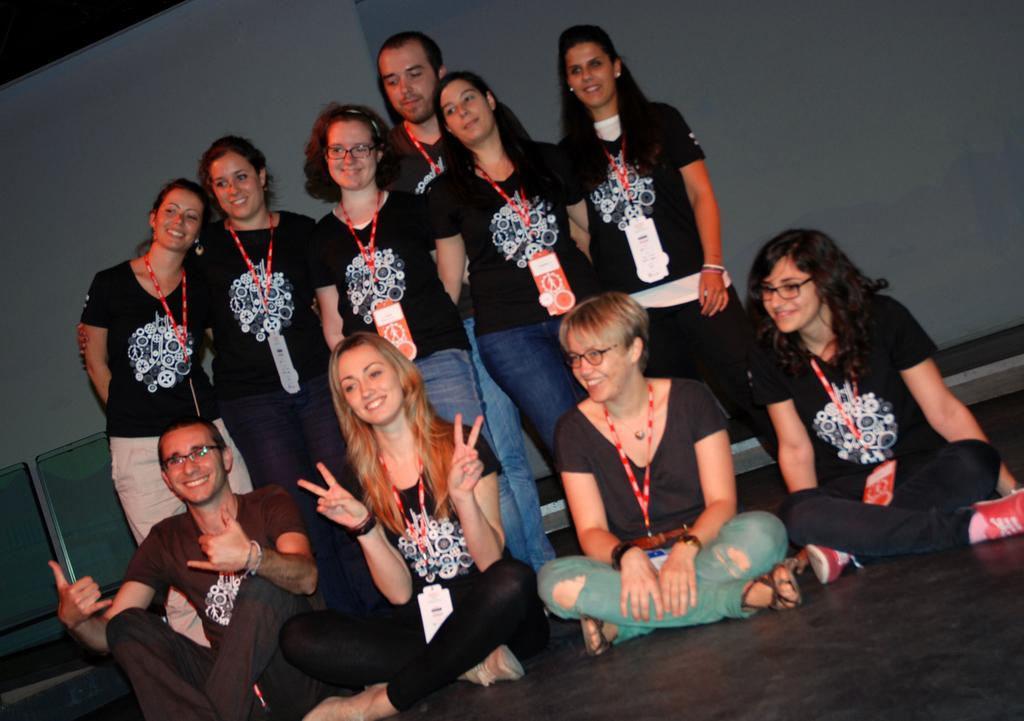How many people are in the image? There is a group of people in the image. What are the people doing in the image? The people are on the floor, looking, and smiling at someone. What can be seen in the background of the image? There are chairs and a wall visible in the background of the image. What type of support can be seen in the image? There is no support visible in the image; it features a group of people on the floor looking at someone. What rhythm is the group of people following in the image? There is no rhythm mentioned or depicted in the image; the people are simply looking and smiling at someone. 